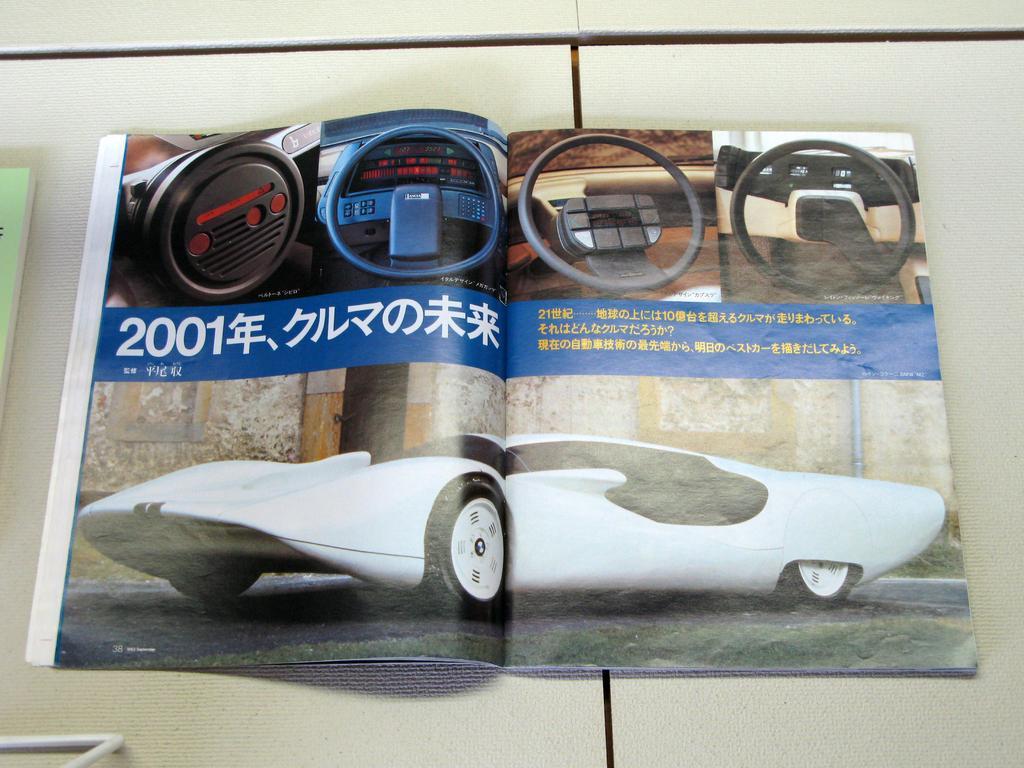Can you describe this image briefly? In this image we can see a book placed on the table. 